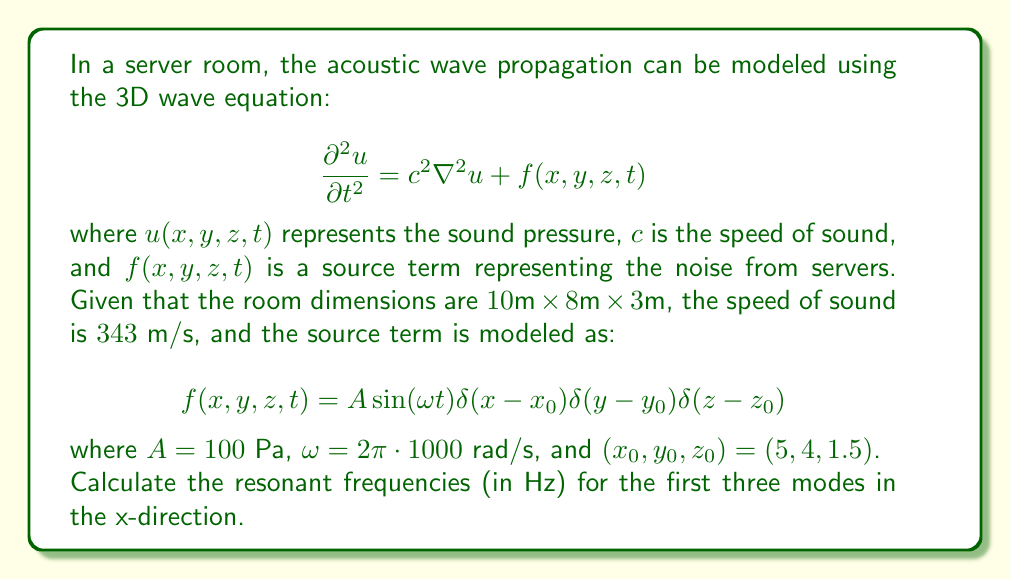Could you help me with this problem? To solve this problem, we'll follow these steps:

1) The resonant frequencies in a rectangular room are given by the formula:

   $$f_{nml} = \frac{c}{2} \sqrt{\left(\frac{n}{L_x}\right)^2 + \left(\frac{m}{L_y}\right)^2 + \left(\frac{l}{L_z}\right)^2}$$

   where $n$, $m$, and $l$ are non-negative integers, and $L_x$, $L_y$, and $L_z$ are the room dimensions.

2) We're asked for the first three modes in the x-direction, so we'll set $m=l=0$ and use $n=1,2,3$.

3) Given:
   - $c = 343 \text{ m/s}$
   - $L_x = 10 \text{ m}$

4) For $n=1$:
   $$f_{100} = \frac{343}{2} \sqrt{\left(\frac{1}{10}\right)^2 + 0^2 + 0^2} = 17.15 \text{ Hz}$$

5) For $n=2$:
   $$f_{200} = \frac{343}{2} \sqrt{\left(\frac{2}{10}\right)^2 + 0^2 + 0^2} = 34.3 \text{ Hz}$$

6) For $n=3$:
   $$f_{300} = \frac{343}{2} \sqrt{\left(\frac{3}{10}\right)^2 + 0^2 + 0^2} = 51.45 \text{ Hz}$$
Answer: 17.15 Hz, 34.3 Hz, 51.45 Hz 